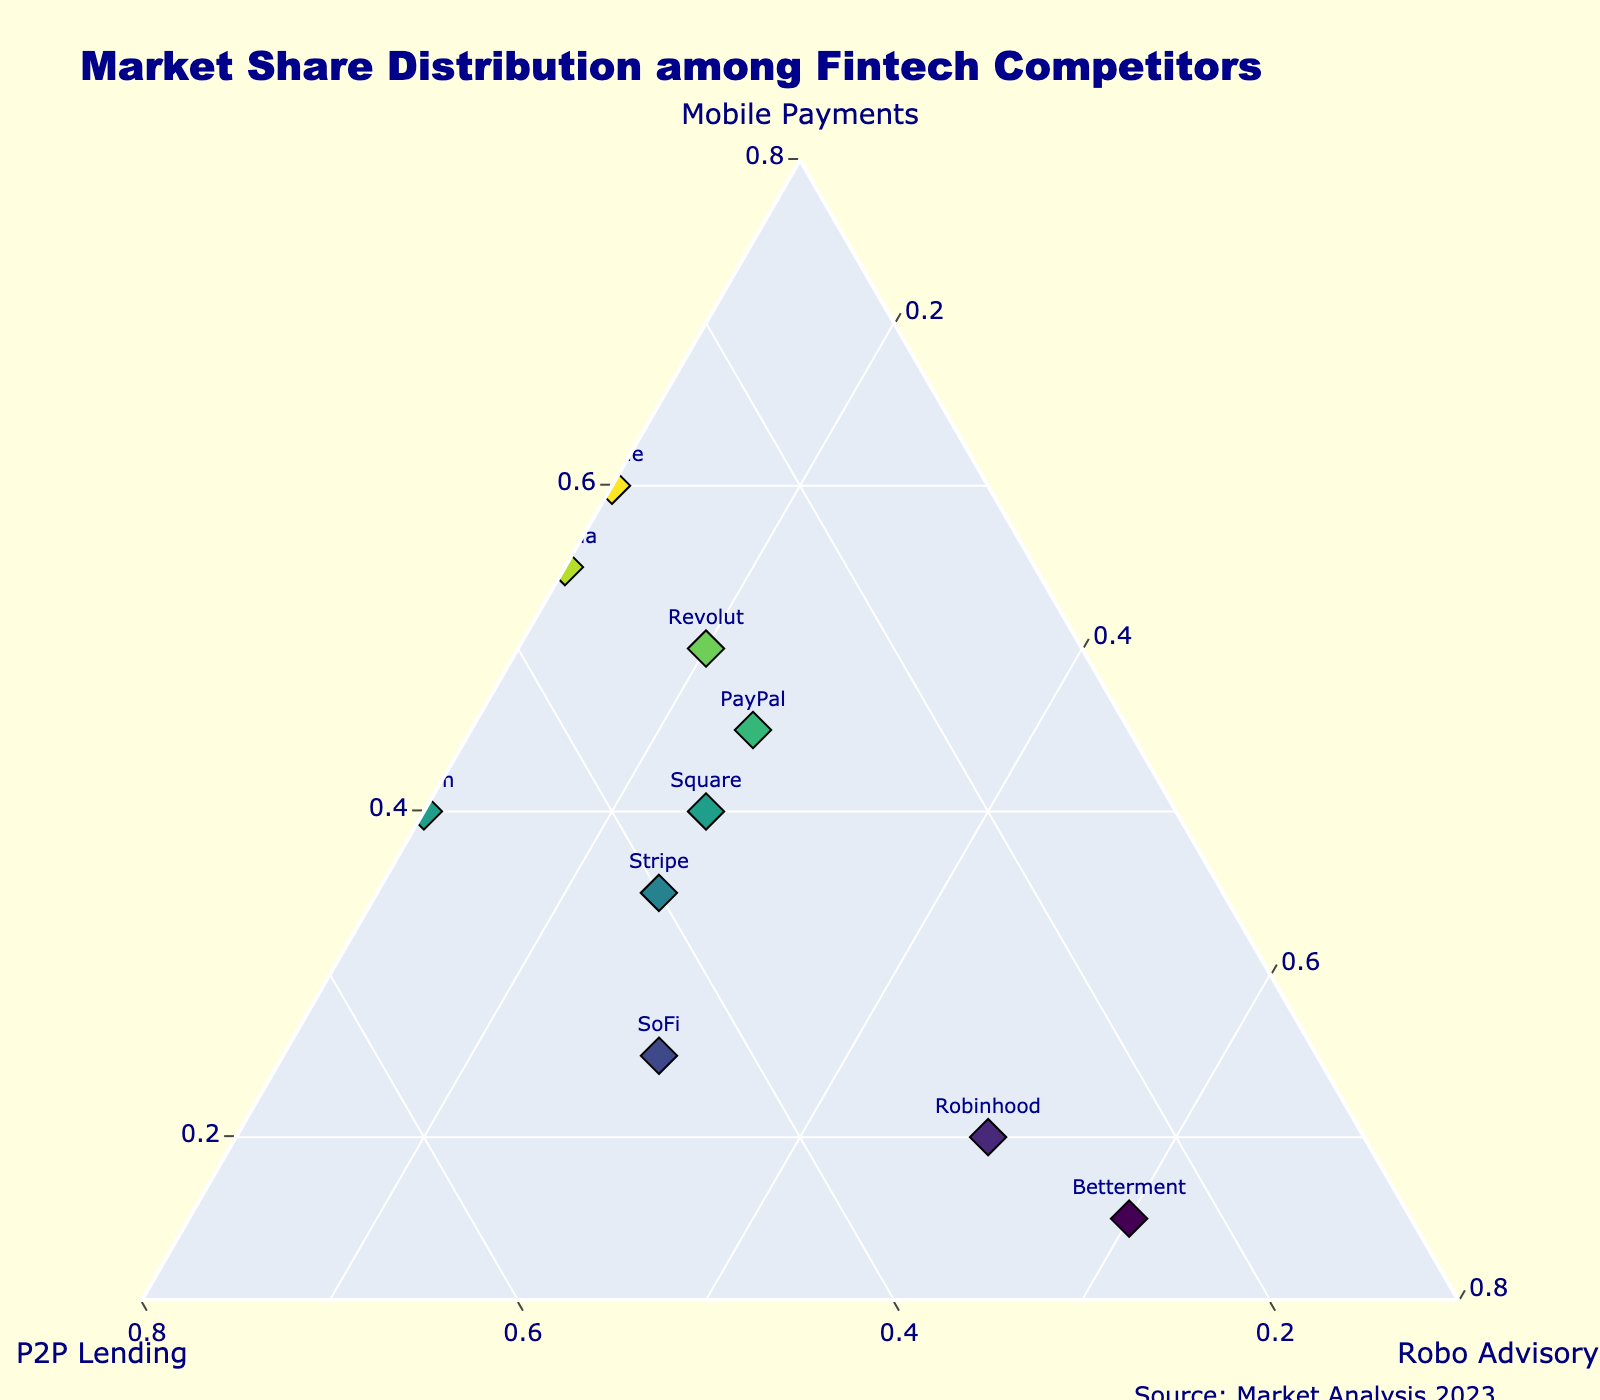What is the title of the figure? The title is written at the top center of the figure.
Answer: Market Share Distribution among Fintech Competitors How many companies have a higher market share in Mobile Payments than in Robo Advisory? By observing the ternary plot, we can count the companies that have higher values along the 'Mobile Payments' axis compared to the 'Robo Advisory' axis.
Answer: 7 Which company has the highest market share in Peer-to-Peer Lending (P2P Lending)? From the plot, identify the point that is the furthest from the origin along the 'P2P Lending' axis.
Answer: Affirm What's the total market share for Square across all three services? To find the total market share for Square, sum its shares in Mobile Payments, P2P Lending, and Robo Advisory. 0.40 + 0.35 + 0.25 = 1.00
Answer: 1.00 Which company is positioned closest to the Robo Advisory corner? The point closest to the Robo Advisory corner will have the highest value in the Robo Advisory axis.
Answer: Betterment Are there any companies with equal market shares in Mobile Payments and P2P Lending? Check the plot for any points that lie equidistant from the Mobile Payments and P2P Lending axes.
Answer: No Which axis has the most companies clustered around high values? By visually inspecting the density of points near the high values, we can determine which axis has the most companies.
Answer: Mobile Payments What's the combined market share in Robo Advisory for PayPal and Stripe? Sum the Robo Advisory shares of PayPal (0.25) and Stripe (0.25). 0.25 + 0.25 = 0.50
Answer: 0.50 Compare Robinhood to SoFi in each service. Which company has a higher market share and in what services? Look at their positions in the ternary plot to compare their values in all three services.
Answer: Robinhood has a higher market share in Robo Advisory, SoFi in Peer-to-Peer Lending, and both are equal in Mobile Payments Which company is the most balanced across all three services and why? A company close to the centroid of the ternary plot suggests a balanced market share. Analyze the company's proximity to the plot center.
Answer: PayPal (values close to 1/3 each) 